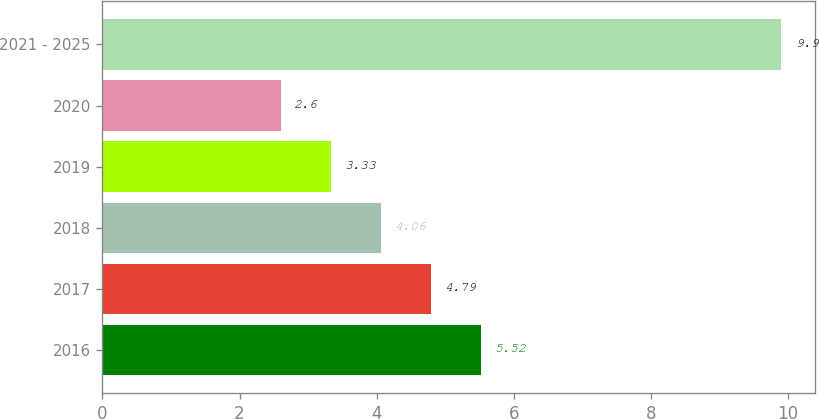Convert chart. <chart><loc_0><loc_0><loc_500><loc_500><bar_chart><fcel>2016<fcel>2017<fcel>2018<fcel>2019<fcel>2020<fcel>2021 - 2025<nl><fcel>5.52<fcel>4.79<fcel>4.06<fcel>3.33<fcel>2.6<fcel>9.9<nl></chart> 